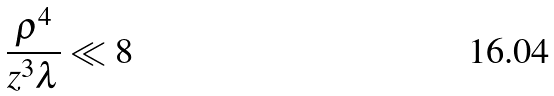<formula> <loc_0><loc_0><loc_500><loc_500>\frac { \rho ^ { 4 } } { z ^ { 3 } \lambda } \ll 8</formula> 